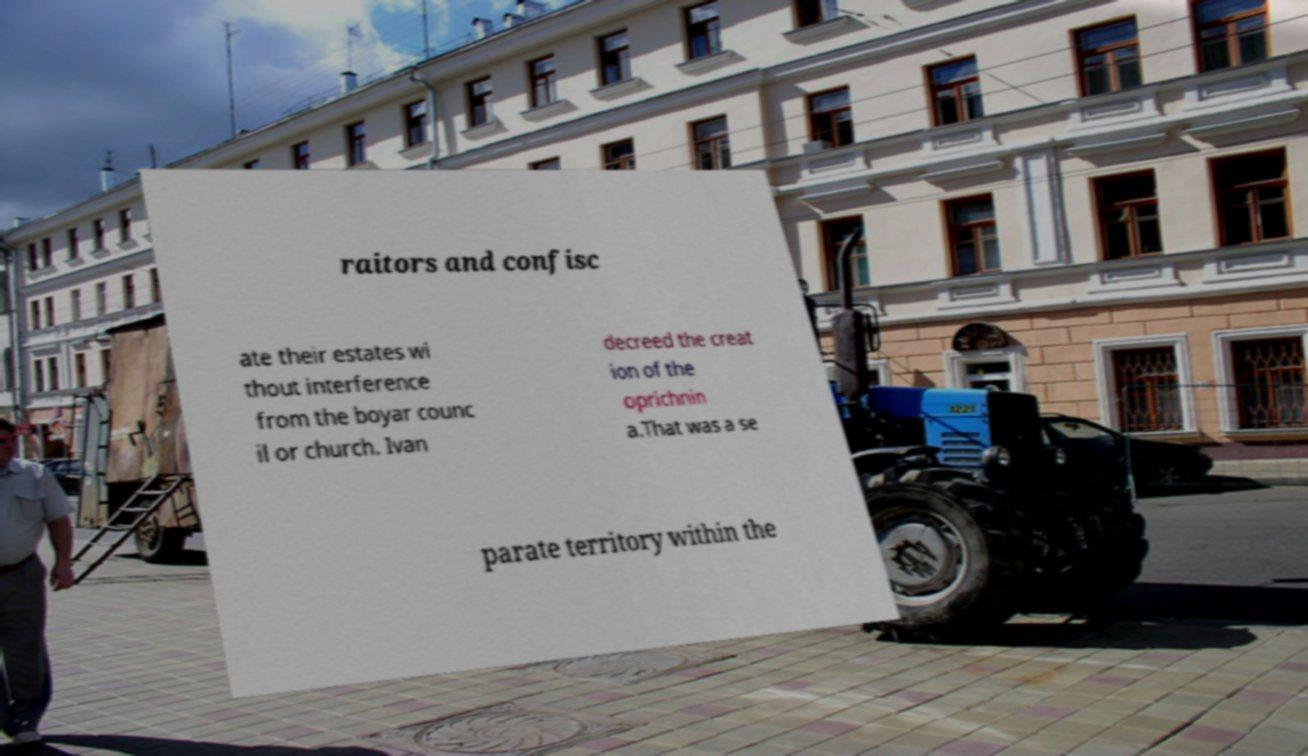What messages or text are displayed in this image? I need them in a readable, typed format. raitors and confisc ate their estates wi thout interference from the boyar counc il or church. Ivan decreed the creat ion of the oprichnin a.That was a se parate territory within the 